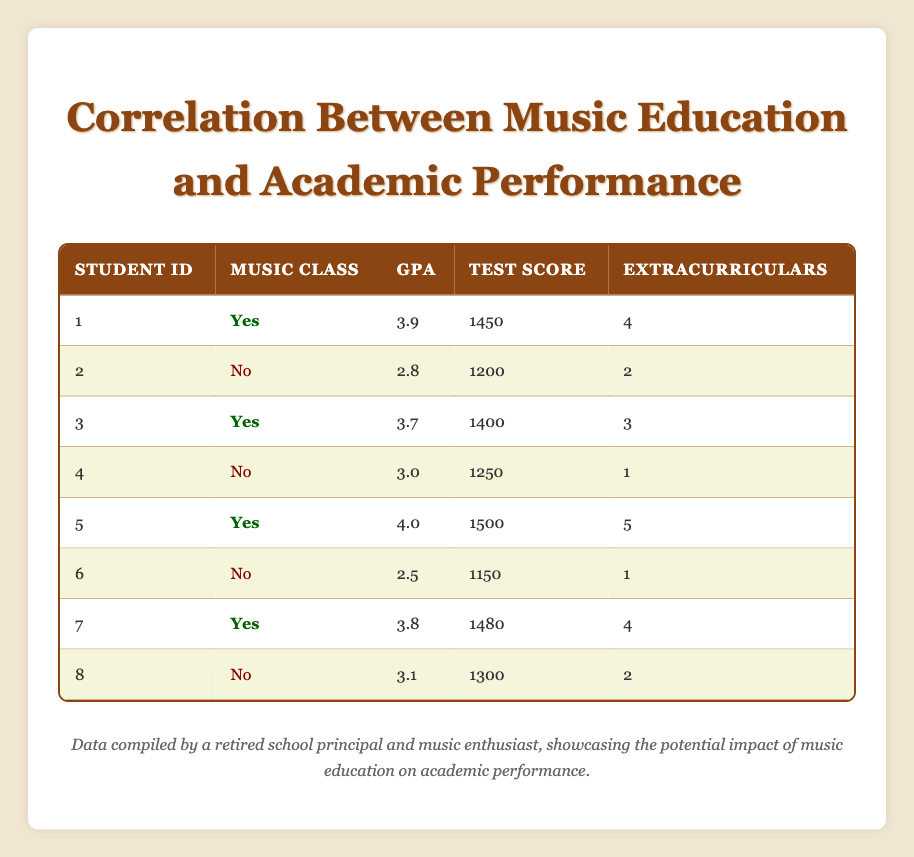What is the GPA of the student who scored 1500 on the standardized test? Referring to the table, the only student who scored 1500 is student ID 5. Checking the GPA column for this student shows that the GPA is 4.0.
Answer: 4.0 How many students participated in music classes? There are four students (student IDs 1, 3, 5, and 7) marked with "Yes" in the Music Class column.
Answer: 4 What is the average GPA of students who did not participate in music classes? There are four students who did not participate (student IDs 2, 4, 6, and 8). Their GPAs are 2.8, 3.0, 2.5, and 3.1 respectively. The average is (2.8 + 3.0 + 2.5 + 3.1) / 4 = 2.85.
Answer: 2.85 Did any student with music class participation score below 3.5 in GPA? Checking the GPAs of students who participated in music classes (students 1, 3, 5, and 7), their GPAs are 3.9, 3.7, 4.0, and 3.8, respectively, all of which are above 3.5.
Answer: No What is the difference in standardized test scores between the highest and lowest scoring students? The highest standardized test score is 1500 (student ID 5) and the lowest is 1150 (student ID 6). The difference is 1500 - 1150 = 350.
Answer: 350 How many extracurricular activities did the student with the lowest GPA participate in? The student with the lowest GPA is student ID 6, who participated in only 1 extracurricular activity.
Answer: 1 What is the median standardized test score of students participating in music classes? The standardized test scores for students in music classes are 1450, 1400, 1500, and 1480. When sorted, the scores are 1400, 1450, 1480, 1500. The median is the average of the two middle values: (1450 + 1480) / 2 = 1465.
Answer: 1465 Is it true that all students who participated in music classes had extracurricular activity involvement of at least 3? Students 1, 3, 5, and 7, who participated in music, had 4, 3, 5, and 4 extracurricular activities respectively. Since student ID 3 has 3, the statement is false.
Answer: No What is the total number of extracurricular activities for students who did not participate in music classes? The extracurricular activities for students who did not participate are 2 (student ID 2), 1 (student ID 4), 1 (student ID 6), and 2 (student ID 8). Summing them gives 2 + 1 + 1 + 2 = 6.
Answer: 6 